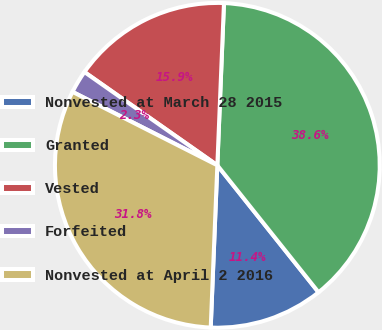Convert chart. <chart><loc_0><loc_0><loc_500><loc_500><pie_chart><fcel>Nonvested at March 28 2015<fcel>Granted<fcel>Vested<fcel>Forfeited<fcel>Nonvested at April 2 2016<nl><fcel>11.36%<fcel>38.64%<fcel>15.91%<fcel>2.27%<fcel>31.82%<nl></chart> 